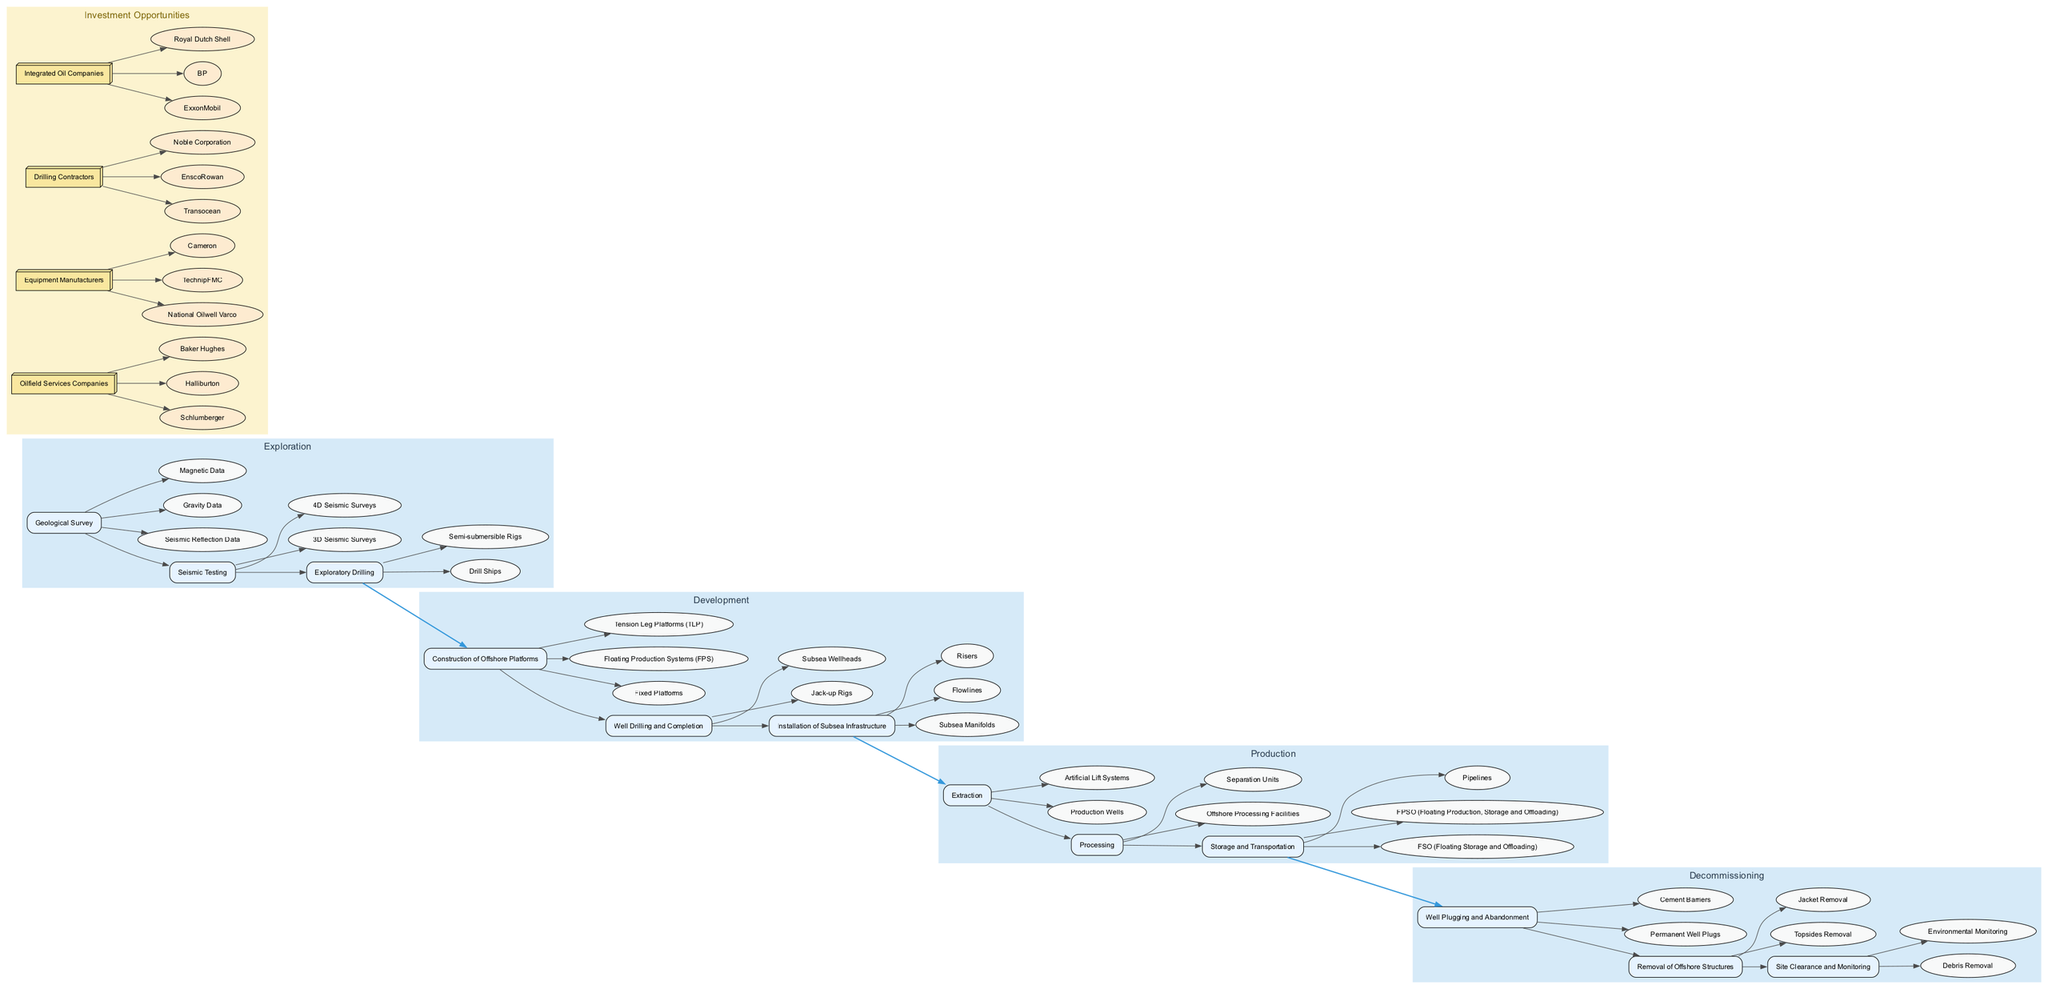What is the first stage in the offshore oil drilling process? The diagram indicates that the first stage is "Exploration". This is directly labeled in the clinical pathway.
Answer: Exploration How many steps are there in the Production stage? Upon examining the Production stage, we can identify three steps: Extraction, Processing, and Storage and Transportation. Therefore, the total is three steps.
Answer: 3 What is the last step in the Decommissioning stage? The last step in the Decommissioning stage, according to the diagram, is "Site Clearance and Monitoring". This is clearly listed among the steps for this stage.
Answer: Site Clearance and Monitoring Which investment opportunity has the example "Transocean"? Looking through the investment opportunities, "Transocean" is listed under the "Drilling Contractors" category. This can be concluded by tracing the connection from the example to its corresponding opportunity.
Answer: Drilling Contractors How many investment opportunities are detailed in the diagram? Counting the investment opportunities listed, there are four in total: Oilfield Services Companies, Equipment Manufacturers, Drilling Contractors, and Integrated Oil Companies. This is identified by simply enumerating the opportunities.
Answer: 4 What key element is associated with the "Exploratory Drilling" step? The key elements associated with the "Exploratory Drilling" step are "Drill Ships" and "Semi-submersible Rigs". By reviewing the specific step, we can find these elements listed.
Answer: Drill Ships, Semi-submersible Rigs Which stage directly precedes the Development stage? The diagram shows that the stage directly preceding the Development stage is Exploration. This can be confirmed by following the connections between the stages in the clinical pathway.
Answer: Exploration Name one example of an Equipment Manufacturer investment opportunity. From the investment opportunities, one example listed under Equipment Manufacturers is "National Oilwell Varco". This is directly referenced under the respective opportunity in the diagram.
Answer: National Oilwell Varco 